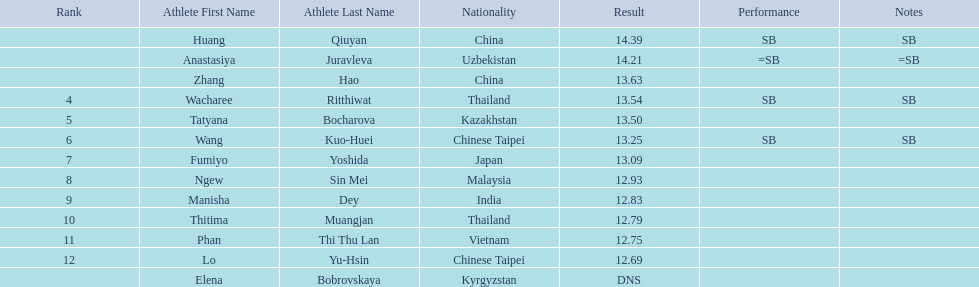What nationality was the woman who won first place? China. 